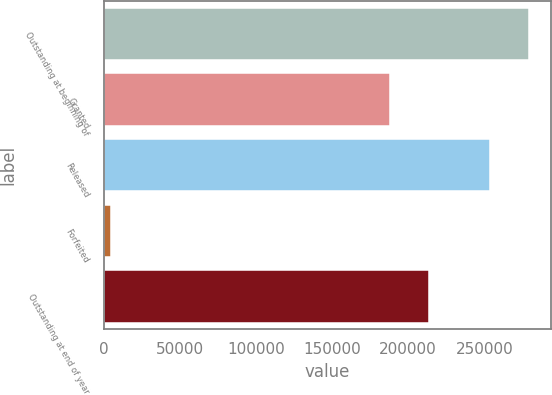Convert chart. <chart><loc_0><loc_0><loc_500><loc_500><bar_chart><fcel>Outstanding at beginning of<fcel>Granted<fcel>Released<fcel>Forfeited<fcel>Outstanding at end of year<nl><fcel>279569<fcel>187794<fcel>253484<fcel>4980<fcel>213879<nl></chart> 